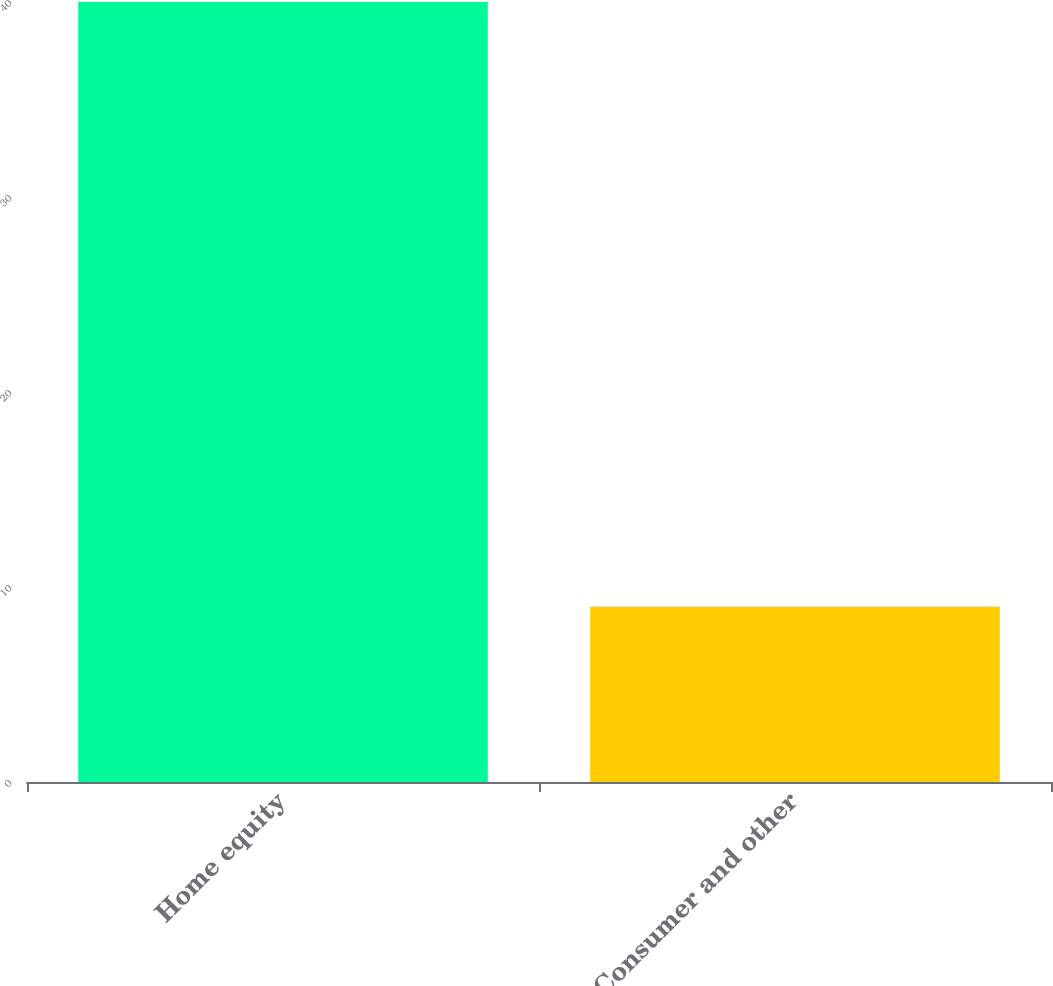Convert chart. <chart><loc_0><loc_0><loc_500><loc_500><bar_chart><fcel>Home equity<fcel>Consumer and other<nl><fcel>40<fcel>9<nl></chart> 